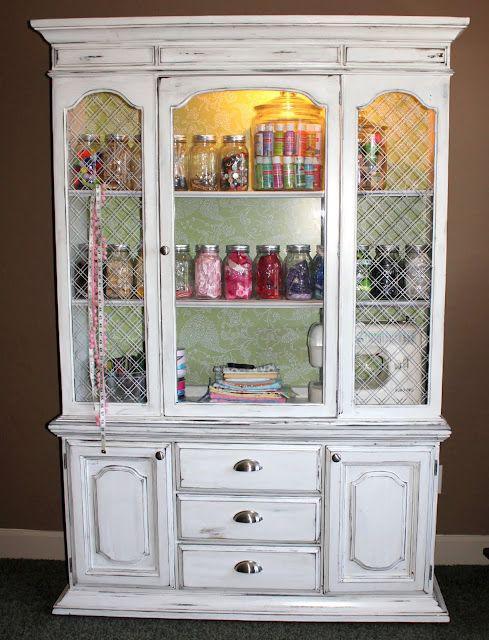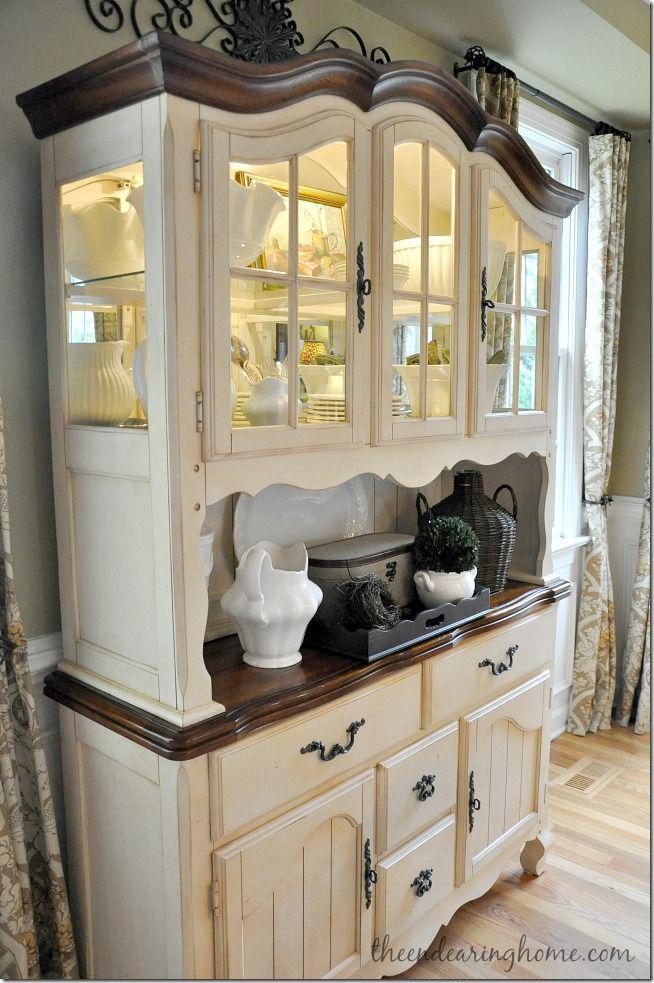The first image is the image on the left, the second image is the image on the right. Examine the images to the left and right. Is the description "The inside of one of the cabinets is an aqua color." accurate? Answer yes or no. No. The first image is the image on the left, the second image is the image on the right. Assess this claim about the two images: "One cabinet has an open space with scrolled edges under the glass-front cabinets.". Correct or not? Answer yes or no. Yes. 